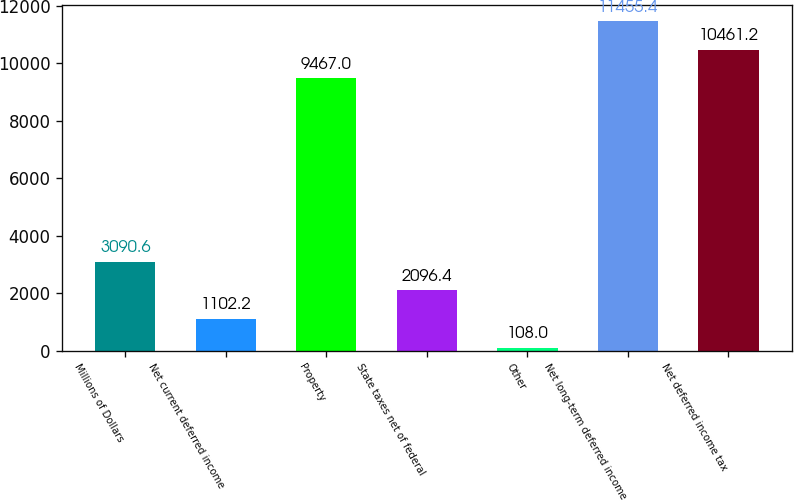Convert chart. <chart><loc_0><loc_0><loc_500><loc_500><bar_chart><fcel>Millions of Dollars<fcel>Net current deferred income<fcel>Property<fcel>State taxes net of federal<fcel>Other<fcel>Net long-term deferred income<fcel>Net deferred income tax<nl><fcel>3090.6<fcel>1102.2<fcel>9467<fcel>2096.4<fcel>108<fcel>11455.4<fcel>10461.2<nl></chart> 